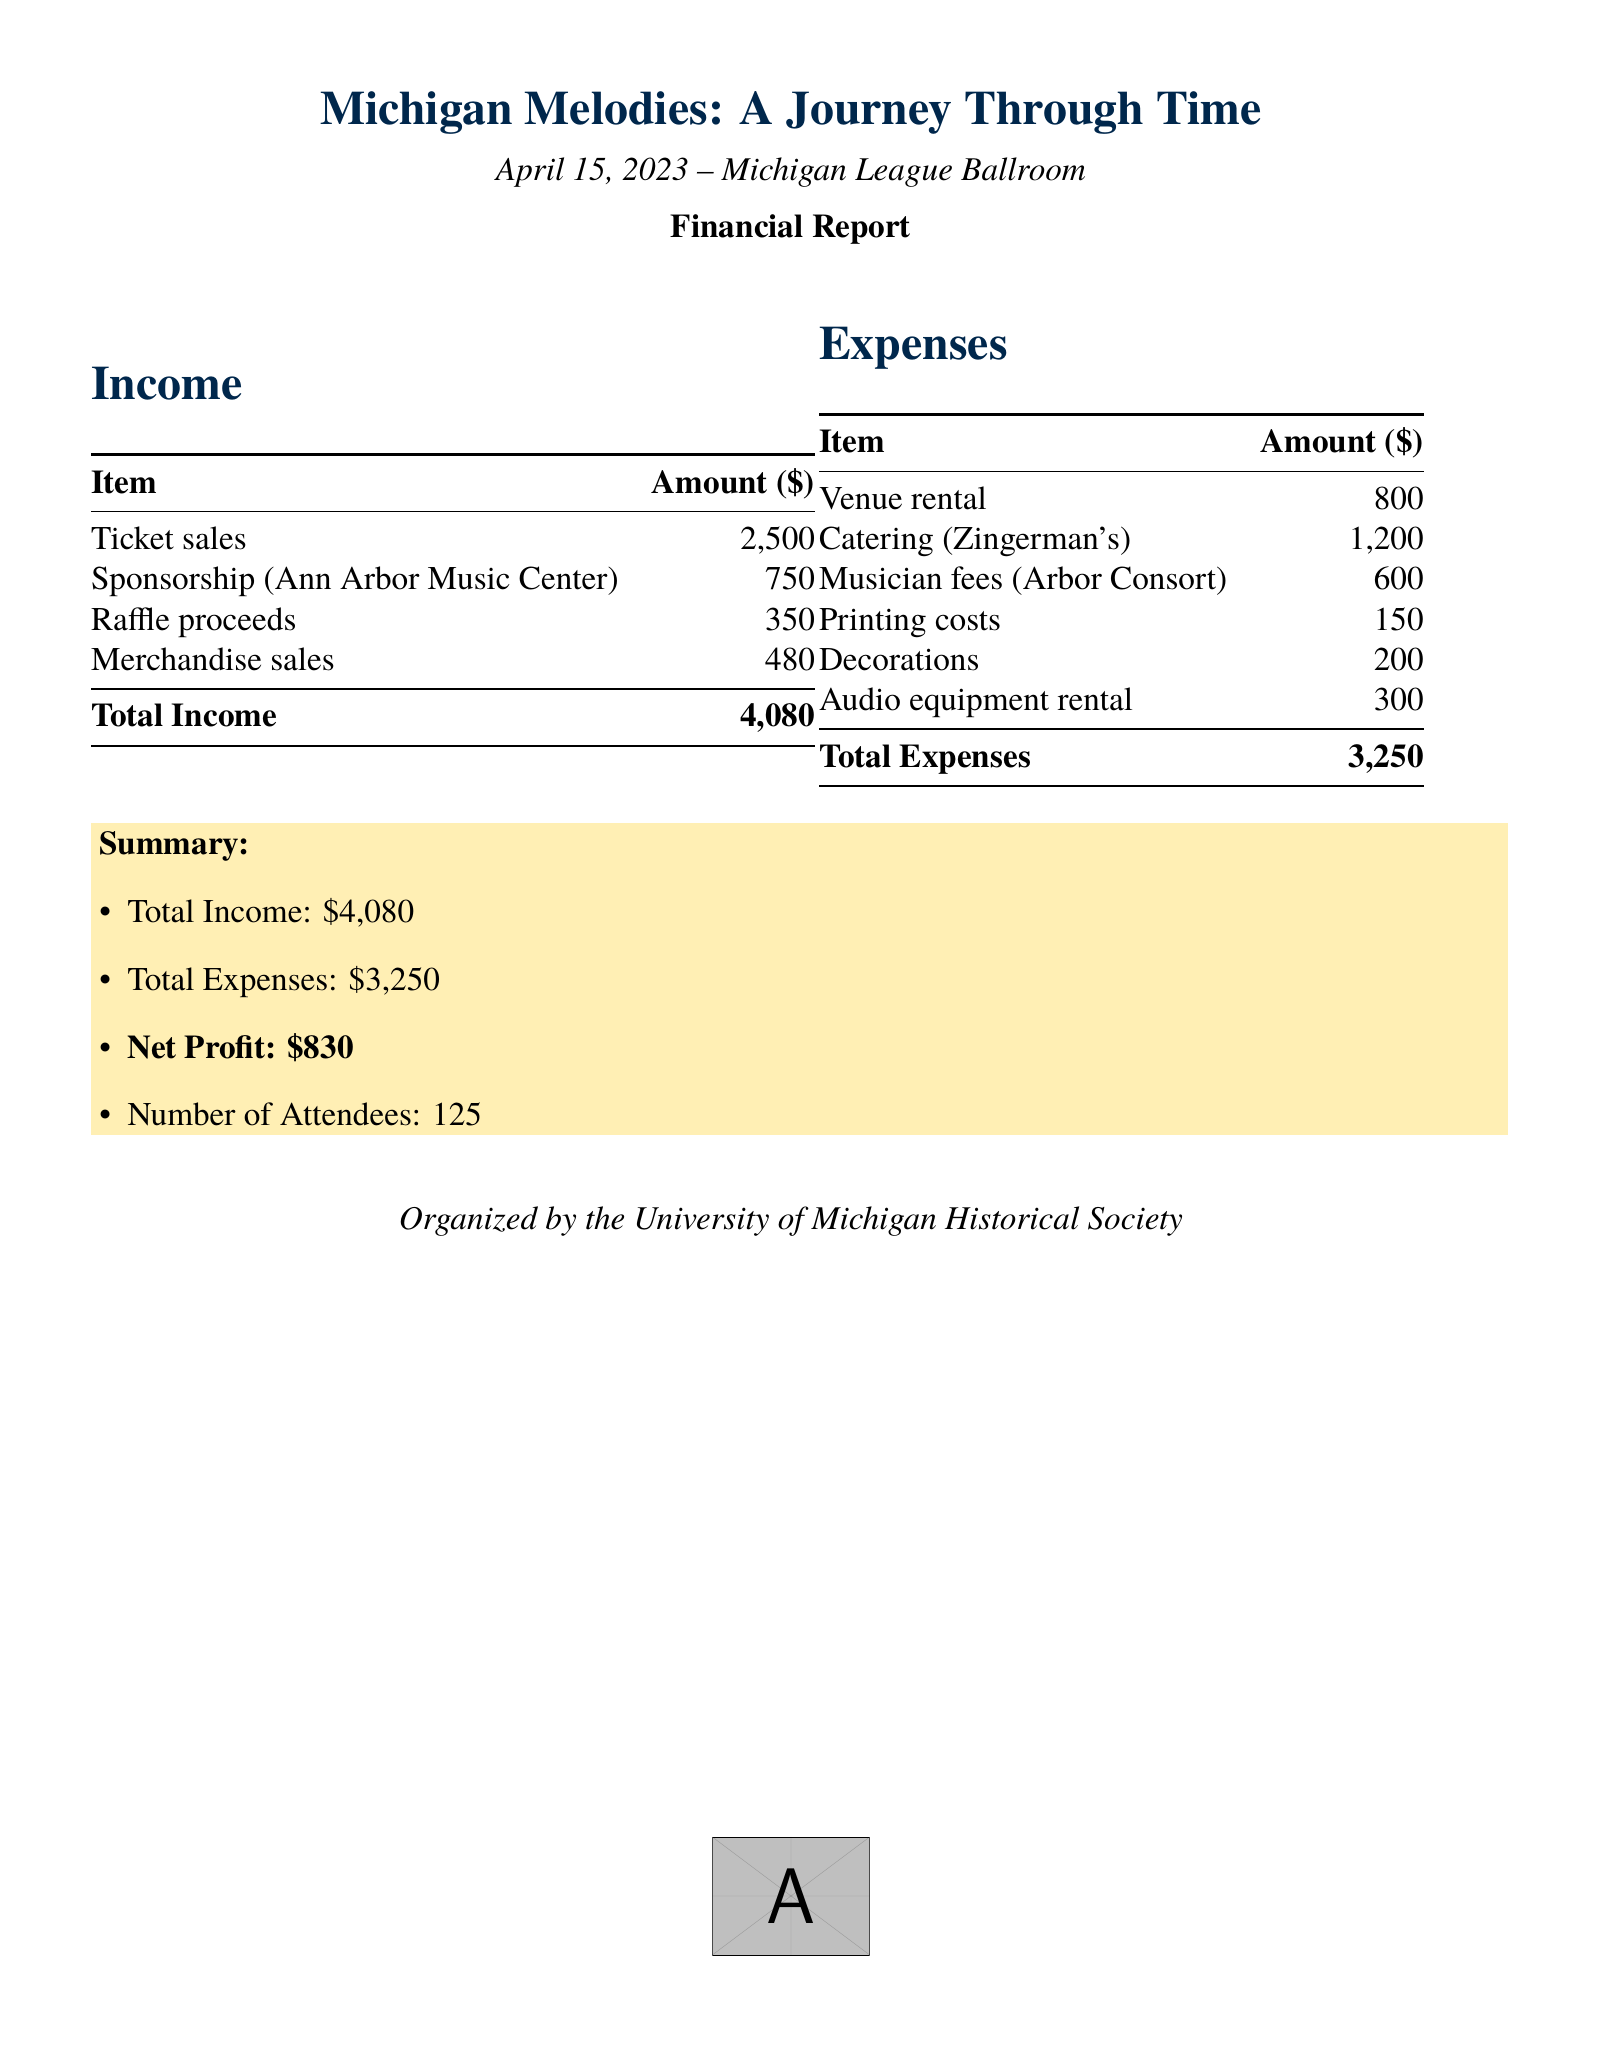What is the event name? The event name is provided in the document under the title section.
Answer: Michigan Melodies: A Journey Through Time When did the event take place? The date of the event is stated prominently in the document.
Answer: April 15, 2023 What is the total income? The total income is calculated and listed in the summary section of the report.
Answer: 4080 What is the total amount spent on catering? The expense for catering is explicitly listed in the expenses table.
Answer: 1200 What is the net profit from the event? The net profit is derived from the total income minus total expenses, mentioned in the summary.
Answer: 830 How many attendees were there? The number of attendees is specified in the summary portion of the document.
Answer: 125 Who sponsored the event? The sponsor's name can be found in the income section of the document.
Answer: Ann Arbor Music Center What was the largest income source? By reviewing the income listed, we identify the highest amount.
Answer: Ticket sales What type of event was organized? The event type is inferred from the title and theme described in the document.
Answer: Themed event 